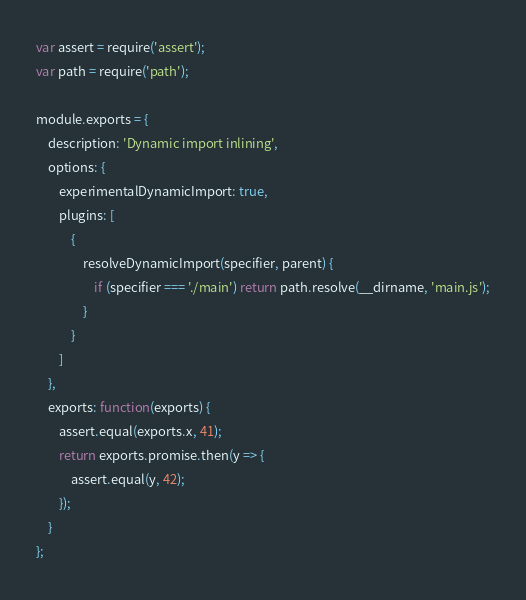Convert code to text. <code><loc_0><loc_0><loc_500><loc_500><_JavaScript_>var assert = require('assert');
var path = require('path');

module.exports = {
	description: 'Dynamic import inlining',
	options: {
		experimentalDynamicImport: true,
		plugins: [
			{
				resolveDynamicImport(specifier, parent) {
					if (specifier === './main') return path.resolve(__dirname, 'main.js');
				}
			}
		]
	},
	exports: function(exports) {
		assert.equal(exports.x, 41);
		return exports.promise.then(y => {
			assert.equal(y, 42);
		});
	}
};
</code> 